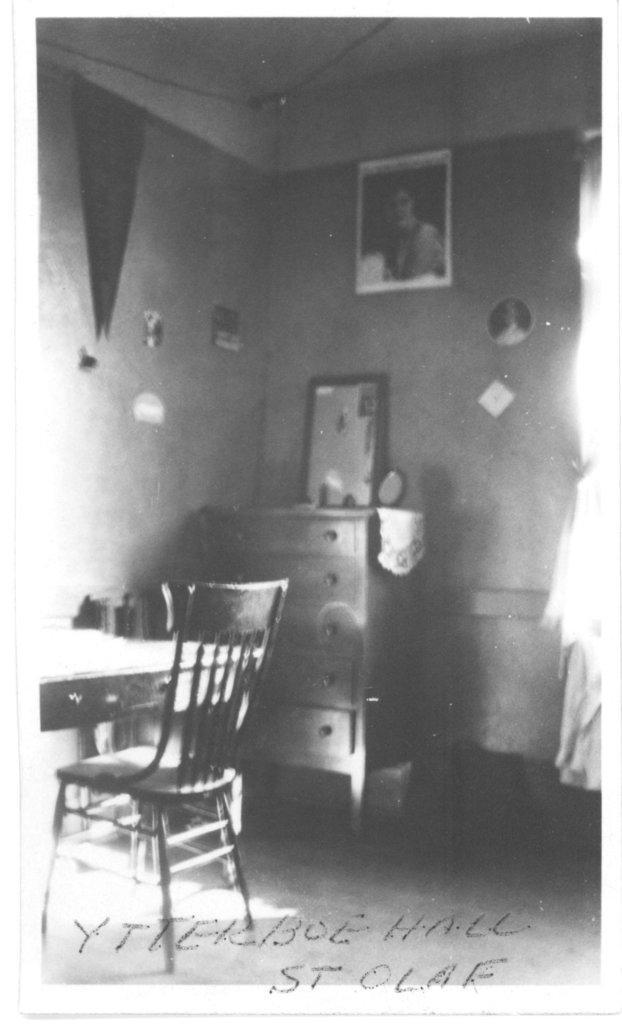Please provide a concise description of this image. This is a black and white picture. Here we can see a chair, table, and a cupboard. This is wall and there is a frame. 